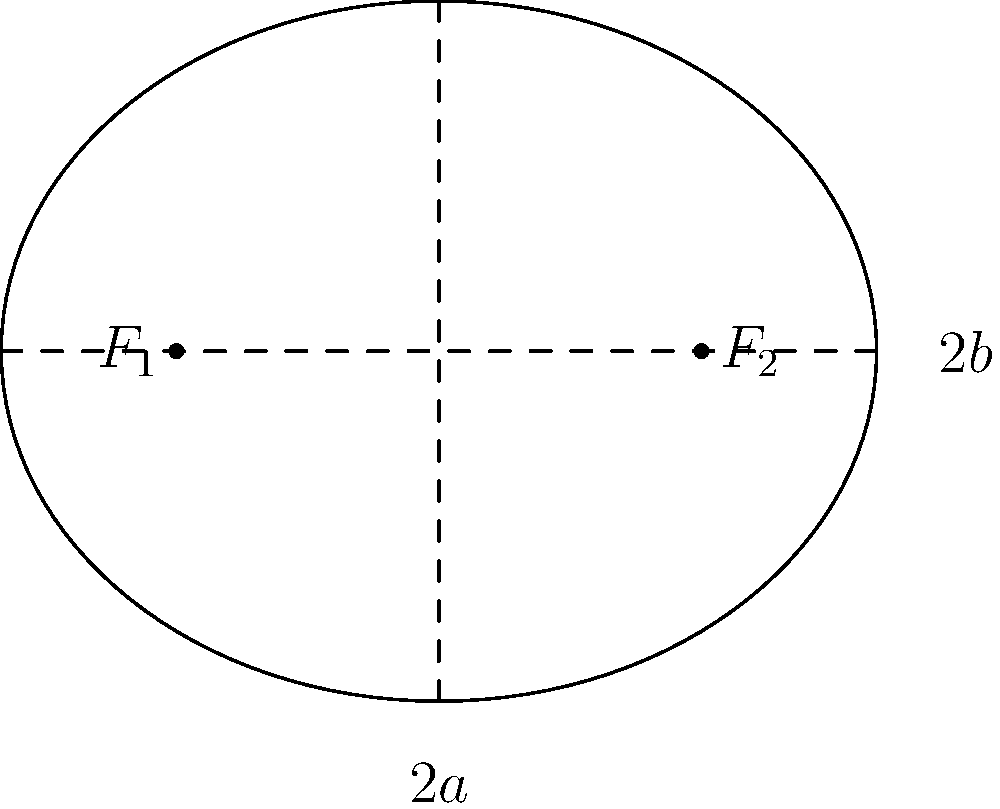In the mystery novel "The Murders of Mrs. Austin and Mrs. Beale" by Jill McGown, Detective Inspector Lloyd discovers a crucial piece of evidence in the shape of an elliptical garden. If the distance between the foci of this elliptical garden is 6 units, and the length of the major axis is 10 units, what is the eccentricity of the ellipse? Let's approach this step-by-step:

1) First, recall the formula for eccentricity of an ellipse:

   $$ e = \frac{c}{a} $$

   where $c$ is the distance from the center to a focus, and $a$ is the length of the semi-major axis.

2) We're given that the distance between the foci is 6 units. This means that $2c = 6$, or $c = 3$.

3) We're also told that the length of the major axis is 10 units. The major axis is $2a$, so:

   $2a = 10$
   $a = 5$

4) Now we have both $c$ and $a$. Let's substitute these into our eccentricity formula:

   $$ e = \frac{c}{a} = \frac{3}{5} = 0.6 $$

5) Therefore, the eccentricity of the elliptical garden is 0.6.

This eccentricity value tells us that the ellipse is moderately elongated, which might be an important clue in Detective Inspector Lloyd's investigation.
Answer: 0.6 